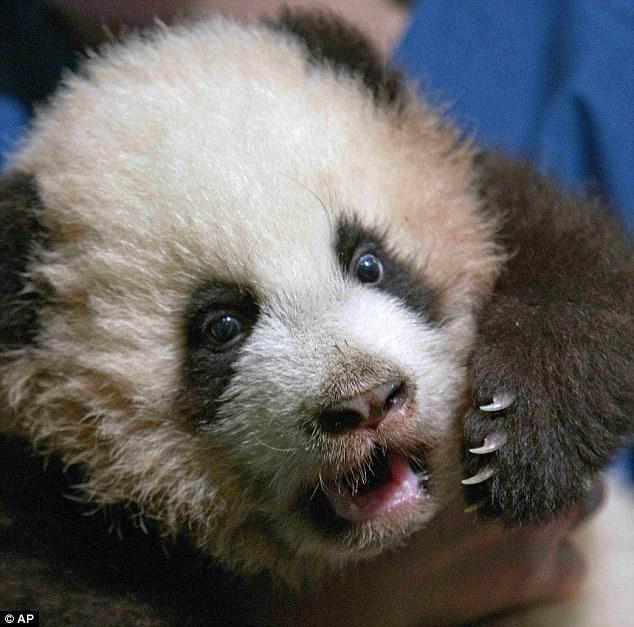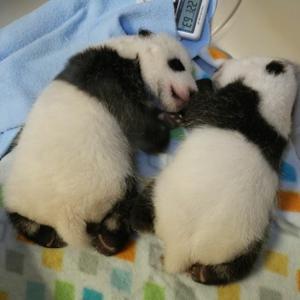The first image is the image on the left, the second image is the image on the right. Assess this claim about the two images: "One image contains twice as many pandas as the other image, and one panda has an open mouth and wide-open eyes.". Correct or not? Answer yes or no. Yes. 